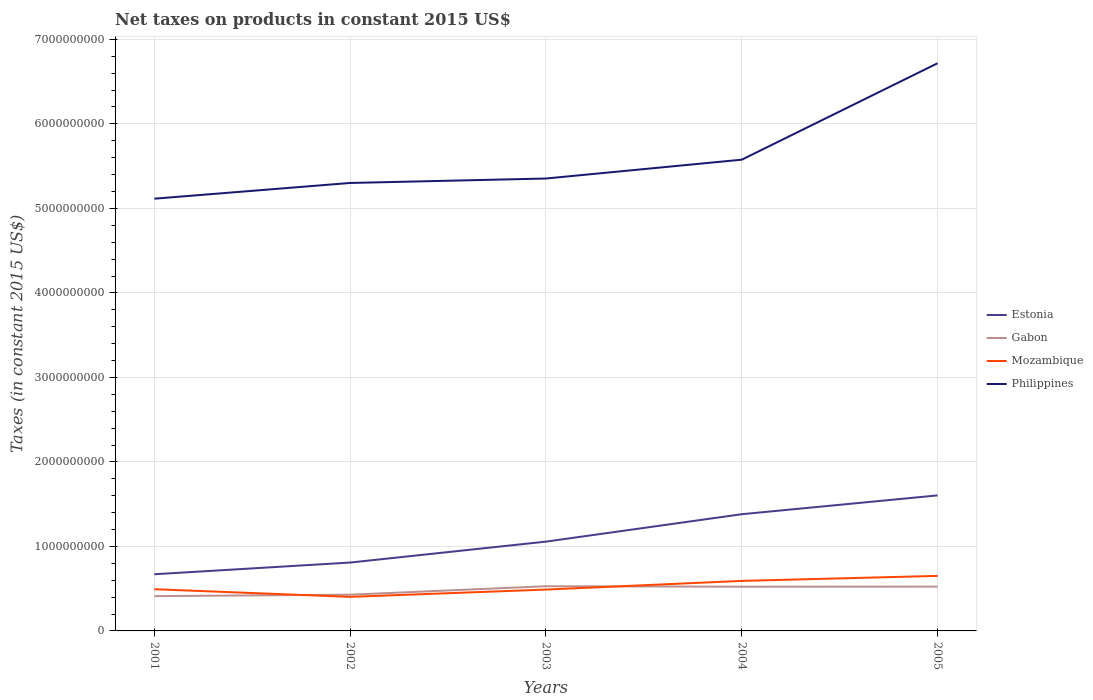Does the line corresponding to Estonia intersect with the line corresponding to Philippines?
Give a very brief answer. No. Is the number of lines equal to the number of legend labels?
Provide a succinct answer. Yes. Across all years, what is the maximum net taxes on products in Gabon?
Keep it short and to the point. 4.12e+08. In which year was the net taxes on products in Estonia maximum?
Offer a terse response. 2001. What is the total net taxes on products in Gabon in the graph?
Give a very brief answer. -1.13e+08. What is the difference between the highest and the second highest net taxes on products in Mozambique?
Your answer should be very brief. 2.48e+08. What is the difference between the highest and the lowest net taxes on products in Gabon?
Your answer should be compact. 3. What is the difference between two consecutive major ticks on the Y-axis?
Keep it short and to the point. 1.00e+09. Are the values on the major ticks of Y-axis written in scientific E-notation?
Provide a short and direct response. No. Does the graph contain any zero values?
Ensure brevity in your answer.  No. Does the graph contain grids?
Offer a terse response. Yes. How many legend labels are there?
Provide a succinct answer. 4. What is the title of the graph?
Make the answer very short. Net taxes on products in constant 2015 US$. What is the label or title of the Y-axis?
Keep it short and to the point. Taxes (in constant 2015 US$). What is the Taxes (in constant 2015 US$) in Estonia in 2001?
Offer a very short reply. 6.71e+08. What is the Taxes (in constant 2015 US$) of Gabon in 2001?
Provide a short and direct response. 4.12e+08. What is the Taxes (in constant 2015 US$) in Mozambique in 2001?
Your response must be concise. 4.94e+08. What is the Taxes (in constant 2015 US$) in Philippines in 2001?
Your answer should be very brief. 5.11e+09. What is the Taxes (in constant 2015 US$) of Estonia in 2002?
Make the answer very short. 8.09e+08. What is the Taxes (in constant 2015 US$) of Gabon in 2002?
Provide a succinct answer. 4.29e+08. What is the Taxes (in constant 2015 US$) of Mozambique in 2002?
Your answer should be compact. 4.03e+08. What is the Taxes (in constant 2015 US$) of Philippines in 2002?
Your answer should be compact. 5.30e+09. What is the Taxes (in constant 2015 US$) in Estonia in 2003?
Give a very brief answer. 1.06e+09. What is the Taxes (in constant 2015 US$) of Gabon in 2003?
Your answer should be compact. 5.29e+08. What is the Taxes (in constant 2015 US$) of Mozambique in 2003?
Your answer should be very brief. 4.89e+08. What is the Taxes (in constant 2015 US$) of Philippines in 2003?
Make the answer very short. 5.35e+09. What is the Taxes (in constant 2015 US$) of Estonia in 2004?
Your answer should be compact. 1.38e+09. What is the Taxes (in constant 2015 US$) in Gabon in 2004?
Give a very brief answer. 5.23e+08. What is the Taxes (in constant 2015 US$) in Mozambique in 2004?
Offer a terse response. 5.92e+08. What is the Taxes (in constant 2015 US$) of Philippines in 2004?
Your response must be concise. 5.58e+09. What is the Taxes (in constant 2015 US$) in Estonia in 2005?
Provide a short and direct response. 1.60e+09. What is the Taxes (in constant 2015 US$) in Gabon in 2005?
Your response must be concise. 5.24e+08. What is the Taxes (in constant 2015 US$) of Mozambique in 2005?
Give a very brief answer. 6.51e+08. What is the Taxes (in constant 2015 US$) of Philippines in 2005?
Provide a succinct answer. 6.72e+09. Across all years, what is the maximum Taxes (in constant 2015 US$) of Estonia?
Keep it short and to the point. 1.60e+09. Across all years, what is the maximum Taxes (in constant 2015 US$) of Gabon?
Provide a short and direct response. 5.29e+08. Across all years, what is the maximum Taxes (in constant 2015 US$) in Mozambique?
Keep it short and to the point. 6.51e+08. Across all years, what is the maximum Taxes (in constant 2015 US$) in Philippines?
Give a very brief answer. 6.72e+09. Across all years, what is the minimum Taxes (in constant 2015 US$) of Estonia?
Your answer should be very brief. 6.71e+08. Across all years, what is the minimum Taxes (in constant 2015 US$) of Gabon?
Ensure brevity in your answer.  4.12e+08. Across all years, what is the minimum Taxes (in constant 2015 US$) of Mozambique?
Provide a short and direct response. 4.03e+08. Across all years, what is the minimum Taxes (in constant 2015 US$) in Philippines?
Make the answer very short. 5.11e+09. What is the total Taxes (in constant 2015 US$) in Estonia in the graph?
Make the answer very short. 5.52e+09. What is the total Taxes (in constant 2015 US$) in Gabon in the graph?
Your answer should be very brief. 2.42e+09. What is the total Taxes (in constant 2015 US$) in Mozambique in the graph?
Keep it short and to the point. 2.63e+09. What is the total Taxes (in constant 2015 US$) in Philippines in the graph?
Provide a short and direct response. 2.81e+1. What is the difference between the Taxes (in constant 2015 US$) of Estonia in 2001 and that in 2002?
Keep it short and to the point. -1.38e+08. What is the difference between the Taxes (in constant 2015 US$) of Gabon in 2001 and that in 2002?
Offer a very short reply. -1.71e+07. What is the difference between the Taxes (in constant 2015 US$) of Mozambique in 2001 and that in 2002?
Offer a terse response. 9.05e+07. What is the difference between the Taxes (in constant 2015 US$) in Philippines in 2001 and that in 2002?
Give a very brief answer. -1.86e+08. What is the difference between the Taxes (in constant 2015 US$) in Estonia in 2001 and that in 2003?
Ensure brevity in your answer.  -3.86e+08. What is the difference between the Taxes (in constant 2015 US$) of Gabon in 2001 and that in 2003?
Provide a short and direct response. -1.17e+08. What is the difference between the Taxes (in constant 2015 US$) of Mozambique in 2001 and that in 2003?
Make the answer very short. 4.09e+06. What is the difference between the Taxes (in constant 2015 US$) of Philippines in 2001 and that in 2003?
Ensure brevity in your answer.  -2.39e+08. What is the difference between the Taxes (in constant 2015 US$) in Estonia in 2001 and that in 2004?
Your answer should be very brief. -7.10e+08. What is the difference between the Taxes (in constant 2015 US$) of Gabon in 2001 and that in 2004?
Your response must be concise. -1.12e+08. What is the difference between the Taxes (in constant 2015 US$) of Mozambique in 2001 and that in 2004?
Ensure brevity in your answer.  -9.84e+07. What is the difference between the Taxes (in constant 2015 US$) of Philippines in 2001 and that in 2004?
Give a very brief answer. -4.62e+08. What is the difference between the Taxes (in constant 2015 US$) in Estonia in 2001 and that in 2005?
Your answer should be compact. -9.33e+08. What is the difference between the Taxes (in constant 2015 US$) in Gabon in 2001 and that in 2005?
Offer a terse response. -1.13e+08. What is the difference between the Taxes (in constant 2015 US$) in Mozambique in 2001 and that in 2005?
Give a very brief answer. -1.58e+08. What is the difference between the Taxes (in constant 2015 US$) of Philippines in 2001 and that in 2005?
Ensure brevity in your answer.  -1.60e+09. What is the difference between the Taxes (in constant 2015 US$) in Estonia in 2002 and that in 2003?
Give a very brief answer. -2.48e+08. What is the difference between the Taxes (in constant 2015 US$) in Gabon in 2002 and that in 2003?
Provide a short and direct response. -1.00e+08. What is the difference between the Taxes (in constant 2015 US$) in Mozambique in 2002 and that in 2003?
Offer a very short reply. -8.65e+07. What is the difference between the Taxes (in constant 2015 US$) of Philippines in 2002 and that in 2003?
Give a very brief answer. -5.27e+07. What is the difference between the Taxes (in constant 2015 US$) of Estonia in 2002 and that in 2004?
Your answer should be very brief. -5.72e+08. What is the difference between the Taxes (in constant 2015 US$) of Gabon in 2002 and that in 2004?
Ensure brevity in your answer.  -9.45e+07. What is the difference between the Taxes (in constant 2015 US$) of Mozambique in 2002 and that in 2004?
Your answer should be very brief. -1.89e+08. What is the difference between the Taxes (in constant 2015 US$) in Philippines in 2002 and that in 2004?
Ensure brevity in your answer.  -2.76e+08. What is the difference between the Taxes (in constant 2015 US$) in Estonia in 2002 and that in 2005?
Your response must be concise. -7.95e+08. What is the difference between the Taxes (in constant 2015 US$) in Gabon in 2002 and that in 2005?
Make the answer very short. -9.55e+07. What is the difference between the Taxes (in constant 2015 US$) in Mozambique in 2002 and that in 2005?
Ensure brevity in your answer.  -2.48e+08. What is the difference between the Taxes (in constant 2015 US$) of Philippines in 2002 and that in 2005?
Make the answer very short. -1.42e+09. What is the difference between the Taxes (in constant 2015 US$) of Estonia in 2003 and that in 2004?
Provide a succinct answer. -3.24e+08. What is the difference between the Taxes (in constant 2015 US$) of Gabon in 2003 and that in 2004?
Give a very brief answer. 5.57e+06. What is the difference between the Taxes (in constant 2015 US$) of Mozambique in 2003 and that in 2004?
Make the answer very short. -1.03e+08. What is the difference between the Taxes (in constant 2015 US$) in Philippines in 2003 and that in 2004?
Your answer should be very brief. -2.23e+08. What is the difference between the Taxes (in constant 2015 US$) in Estonia in 2003 and that in 2005?
Keep it short and to the point. -5.47e+08. What is the difference between the Taxes (in constant 2015 US$) in Gabon in 2003 and that in 2005?
Your response must be concise. 4.59e+06. What is the difference between the Taxes (in constant 2015 US$) of Mozambique in 2003 and that in 2005?
Provide a succinct answer. -1.62e+08. What is the difference between the Taxes (in constant 2015 US$) in Philippines in 2003 and that in 2005?
Make the answer very short. -1.36e+09. What is the difference between the Taxes (in constant 2015 US$) of Estonia in 2004 and that in 2005?
Provide a short and direct response. -2.23e+08. What is the difference between the Taxes (in constant 2015 US$) of Gabon in 2004 and that in 2005?
Make the answer very short. -9.85e+05. What is the difference between the Taxes (in constant 2015 US$) in Mozambique in 2004 and that in 2005?
Your answer should be very brief. -5.92e+07. What is the difference between the Taxes (in constant 2015 US$) of Philippines in 2004 and that in 2005?
Offer a very short reply. -1.14e+09. What is the difference between the Taxes (in constant 2015 US$) of Estonia in 2001 and the Taxes (in constant 2015 US$) of Gabon in 2002?
Ensure brevity in your answer.  2.42e+08. What is the difference between the Taxes (in constant 2015 US$) of Estonia in 2001 and the Taxes (in constant 2015 US$) of Mozambique in 2002?
Your answer should be compact. 2.68e+08. What is the difference between the Taxes (in constant 2015 US$) of Estonia in 2001 and the Taxes (in constant 2015 US$) of Philippines in 2002?
Keep it short and to the point. -4.63e+09. What is the difference between the Taxes (in constant 2015 US$) of Gabon in 2001 and the Taxes (in constant 2015 US$) of Mozambique in 2002?
Keep it short and to the point. 8.76e+06. What is the difference between the Taxes (in constant 2015 US$) of Gabon in 2001 and the Taxes (in constant 2015 US$) of Philippines in 2002?
Offer a very short reply. -4.89e+09. What is the difference between the Taxes (in constant 2015 US$) of Mozambique in 2001 and the Taxes (in constant 2015 US$) of Philippines in 2002?
Your response must be concise. -4.81e+09. What is the difference between the Taxes (in constant 2015 US$) in Estonia in 2001 and the Taxes (in constant 2015 US$) in Gabon in 2003?
Give a very brief answer. 1.42e+08. What is the difference between the Taxes (in constant 2015 US$) in Estonia in 2001 and the Taxes (in constant 2015 US$) in Mozambique in 2003?
Give a very brief answer. 1.81e+08. What is the difference between the Taxes (in constant 2015 US$) of Estonia in 2001 and the Taxes (in constant 2015 US$) of Philippines in 2003?
Provide a short and direct response. -4.68e+09. What is the difference between the Taxes (in constant 2015 US$) of Gabon in 2001 and the Taxes (in constant 2015 US$) of Mozambique in 2003?
Keep it short and to the point. -7.77e+07. What is the difference between the Taxes (in constant 2015 US$) of Gabon in 2001 and the Taxes (in constant 2015 US$) of Philippines in 2003?
Offer a terse response. -4.94e+09. What is the difference between the Taxes (in constant 2015 US$) of Mozambique in 2001 and the Taxes (in constant 2015 US$) of Philippines in 2003?
Ensure brevity in your answer.  -4.86e+09. What is the difference between the Taxes (in constant 2015 US$) of Estonia in 2001 and the Taxes (in constant 2015 US$) of Gabon in 2004?
Your response must be concise. 1.47e+08. What is the difference between the Taxes (in constant 2015 US$) of Estonia in 2001 and the Taxes (in constant 2015 US$) of Mozambique in 2004?
Keep it short and to the point. 7.87e+07. What is the difference between the Taxes (in constant 2015 US$) of Estonia in 2001 and the Taxes (in constant 2015 US$) of Philippines in 2004?
Give a very brief answer. -4.91e+09. What is the difference between the Taxes (in constant 2015 US$) of Gabon in 2001 and the Taxes (in constant 2015 US$) of Mozambique in 2004?
Your response must be concise. -1.80e+08. What is the difference between the Taxes (in constant 2015 US$) in Gabon in 2001 and the Taxes (in constant 2015 US$) in Philippines in 2004?
Your response must be concise. -5.16e+09. What is the difference between the Taxes (in constant 2015 US$) of Mozambique in 2001 and the Taxes (in constant 2015 US$) of Philippines in 2004?
Make the answer very short. -5.08e+09. What is the difference between the Taxes (in constant 2015 US$) of Estonia in 2001 and the Taxes (in constant 2015 US$) of Gabon in 2005?
Give a very brief answer. 1.46e+08. What is the difference between the Taxes (in constant 2015 US$) in Estonia in 2001 and the Taxes (in constant 2015 US$) in Mozambique in 2005?
Your answer should be very brief. 1.95e+07. What is the difference between the Taxes (in constant 2015 US$) of Estonia in 2001 and the Taxes (in constant 2015 US$) of Philippines in 2005?
Your answer should be compact. -6.05e+09. What is the difference between the Taxes (in constant 2015 US$) in Gabon in 2001 and the Taxes (in constant 2015 US$) in Mozambique in 2005?
Offer a very short reply. -2.39e+08. What is the difference between the Taxes (in constant 2015 US$) of Gabon in 2001 and the Taxes (in constant 2015 US$) of Philippines in 2005?
Your answer should be compact. -6.31e+09. What is the difference between the Taxes (in constant 2015 US$) in Mozambique in 2001 and the Taxes (in constant 2015 US$) in Philippines in 2005?
Offer a terse response. -6.22e+09. What is the difference between the Taxes (in constant 2015 US$) in Estonia in 2002 and the Taxes (in constant 2015 US$) in Gabon in 2003?
Your answer should be very brief. 2.80e+08. What is the difference between the Taxes (in constant 2015 US$) in Estonia in 2002 and the Taxes (in constant 2015 US$) in Mozambique in 2003?
Provide a succinct answer. 3.20e+08. What is the difference between the Taxes (in constant 2015 US$) in Estonia in 2002 and the Taxes (in constant 2015 US$) in Philippines in 2003?
Provide a short and direct response. -4.54e+09. What is the difference between the Taxes (in constant 2015 US$) of Gabon in 2002 and the Taxes (in constant 2015 US$) of Mozambique in 2003?
Provide a succinct answer. -6.06e+07. What is the difference between the Taxes (in constant 2015 US$) of Gabon in 2002 and the Taxes (in constant 2015 US$) of Philippines in 2003?
Provide a short and direct response. -4.92e+09. What is the difference between the Taxes (in constant 2015 US$) of Mozambique in 2002 and the Taxes (in constant 2015 US$) of Philippines in 2003?
Make the answer very short. -4.95e+09. What is the difference between the Taxes (in constant 2015 US$) in Estonia in 2002 and the Taxes (in constant 2015 US$) in Gabon in 2004?
Keep it short and to the point. 2.86e+08. What is the difference between the Taxes (in constant 2015 US$) in Estonia in 2002 and the Taxes (in constant 2015 US$) in Mozambique in 2004?
Your answer should be very brief. 2.17e+08. What is the difference between the Taxes (in constant 2015 US$) in Estonia in 2002 and the Taxes (in constant 2015 US$) in Philippines in 2004?
Offer a terse response. -4.77e+09. What is the difference between the Taxes (in constant 2015 US$) of Gabon in 2002 and the Taxes (in constant 2015 US$) of Mozambique in 2004?
Your answer should be compact. -1.63e+08. What is the difference between the Taxes (in constant 2015 US$) of Gabon in 2002 and the Taxes (in constant 2015 US$) of Philippines in 2004?
Provide a succinct answer. -5.15e+09. What is the difference between the Taxes (in constant 2015 US$) in Mozambique in 2002 and the Taxes (in constant 2015 US$) in Philippines in 2004?
Your answer should be compact. -5.17e+09. What is the difference between the Taxes (in constant 2015 US$) of Estonia in 2002 and the Taxes (in constant 2015 US$) of Gabon in 2005?
Ensure brevity in your answer.  2.85e+08. What is the difference between the Taxes (in constant 2015 US$) of Estonia in 2002 and the Taxes (in constant 2015 US$) of Mozambique in 2005?
Provide a succinct answer. 1.58e+08. What is the difference between the Taxes (in constant 2015 US$) in Estonia in 2002 and the Taxes (in constant 2015 US$) in Philippines in 2005?
Make the answer very short. -5.91e+09. What is the difference between the Taxes (in constant 2015 US$) of Gabon in 2002 and the Taxes (in constant 2015 US$) of Mozambique in 2005?
Your answer should be very brief. -2.22e+08. What is the difference between the Taxes (in constant 2015 US$) in Gabon in 2002 and the Taxes (in constant 2015 US$) in Philippines in 2005?
Provide a succinct answer. -6.29e+09. What is the difference between the Taxes (in constant 2015 US$) of Mozambique in 2002 and the Taxes (in constant 2015 US$) of Philippines in 2005?
Your answer should be compact. -6.31e+09. What is the difference between the Taxes (in constant 2015 US$) of Estonia in 2003 and the Taxes (in constant 2015 US$) of Gabon in 2004?
Make the answer very short. 5.33e+08. What is the difference between the Taxes (in constant 2015 US$) in Estonia in 2003 and the Taxes (in constant 2015 US$) in Mozambique in 2004?
Make the answer very short. 4.65e+08. What is the difference between the Taxes (in constant 2015 US$) of Estonia in 2003 and the Taxes (in constant 2015 US$) of Philippines in 2004?
Your response must be concise. -4.52e+09. What is the difference between the Taxes (in constant 2015 US$) in Gabon in 2003 and the Taxes (in constant 2015 US$) in Mozambique in 2004?
Ensure brevity in your answer.  -6.31e+07. What is the difference between the Taxes (in constant 2015 US$) in Gabon in 2003 and the Taxes (in constant 2015 US$) in Philippines in 2004?
Provide a succinct answer. -5.05e+09. What is the difference between the Taxes (in constant 2015 US$) in Mozambique in 2003 and the Taxes (in constant 2015 US$) in Philippines in 2004?
Provide a succinct answer. -5.09e+09. What is the difference between the Taxes (in constant 2015 US$) in Estonia in 2003 and the Taxes (in constant 2015 US$) in Gabon in 2005?
Provide a succinct answer. 5.32e+08. What is the difference between the Taxes (in constant 2015 US$) of Estonia in 2003 and the Taxes (in constant 2015 US$) of Mozambique in 2005?
Your response must be concise. 4.06e+08. What is the difference between the Taxes (in constant 2015 US$) of Estonia in 2003 and the Taxes (in constant 2015 US$) of Philippines in 2005?
Your answer should be very brief. -5.66e+09. What is the difference between the Taxes (in constant 2015 US$) of Gabon in 2003 and the Taxes (in constant 2015 US$) of Mozambique in 2005?
Offer a very short reply. -1.22e+08. What is the difference between the Taxes (in constant 2015 US$) of Gabon in 2003 and the Taxes (in constant 2015 US$) of Philippines in 2005?
Give a very brief answer. -6.19e+09. What is the difference between the Taxes (in constant 2015 US$) of Mozambique in 2003 and the Taxes (in constant 2015 US$) of Philippines in 2005?
Offer a very short reply. -6.23e+09. What is the difference between the Taxes (in constant 2015 US$) of Estonia in 2004 and the Taxes (in constant 2015 US$) of Gabon in 2005?
Give a very brief answer. 8.57e+08. What is the difference between the Taxes (in constant 2015 US$) in Estonia in 2004 and the Taxes (in constant 2015 US$) in Mozambique in 2005?
Your response must be concise. 7.30e+08. What is the difference between the Taxes (in constant 2015 US$) in Estonia in 2004 and the Taxes (in constant 2015 US$) in Philippines in 2005?
Provide a short and direct response. -5.34e+09. What is the difference between the Taxes (in constant 2015 US$) in Gabon in 2004 and the Taxes (in constant 2015 US$) in Mozambique in 2005?
Offer a very short reply. -1.28e+08. What is the difference between the Taxes (in constant 2015 US$) of Gabon in 2004 and the Taxes (in constant 2015 US$) of Philippines in 2005?
Keep it short and to the point. -6.19e+09. What is the difference between the Taxes (in constant 2015 US$) of Mozambique in 2004 and the Taxes (in constant 2015 US$) of Philippines in 2005?
Provide a short and direct response. -6.13e+09. What is the average Taxes (in constant 2015 US$) of Estonia per year?
Keep it short and to the point. 1.10e+09. What is the average Taxes (in constant 2015 US$) in Gabon per year?
Give a very brief answer. 4.83e+08. What is the average Taxes (in constant 2015 US$) of Mozambique per year?
Make the answer very short. 5.26e+08. What is the average Taxes (in constant 2015 US$) of Philippines per year?
Your response must be concise. 5.61e+09. In the year 2001, what is the difference between the Taxes (in constant 2015 US$) of Estonia and Taxes (in constant 2015 US$) of Gabon?
Ensure brevity in your answer.  2.59e+08. In the year 2001, what is the difference between the Taxes (in constant 2015 US$) of Estonia and Taxes (in constant 2015 US$) of Mozambique?
Ensure brevity in your answer.  1.77e+08. In the year 2001, what is the difference between the Taxes (in constant 2015 US$) of Estonia and Taxes (in constant 2015 US$) of Philippines?
Your answer should be very brief. -4.44e+09. In the year 2001, what is the difference between the Taxes (in constant 2015 US$) of Gabon and Taxes (in constant 2015 US$) of Mozambique?
Offer a terse response. -8.18e+07. In the year 2001, what is the difference between the Taxes (in constant 2015 US$) of Gabon and Taxes (in constant 2015 US$) of Philippines?
Your answer should be very brief. -4.70e+09. In the year 2001, what is the difference between the Taxes (in constant 2015 US$) in Mozambique and Taxes (in constant 2015 US$) in Philippines?
Offer a terse response. -4.62e+09. In the year 2002, what is the difference between the Taxes (in constant 2015 US$) in Estonia and Taxes (in constant 2015 US$) in Gabon?
Your answer should be very brief. 3.80e+08. In the year 2002, what is the difference between the Taxes (in constant 2015 US$) of Estonia and Taxes (in constant 2015 US$) of Mozambique?
Your response must be concise. 4.06e+08. In the year 2002, what is the difference between the Taxes (in constant 2015 US$) of Estonia and Taxes (in constant 2015 US$) of Philippines?
Offer a terse response. -4.49e+09. In the year 2002, what is the difference between the Taxes (in constant 2015 US$) of Gabon and Taxes (in constant 2015 US$) of Mozambique?
Your response must be concise. 2.58e+07. In the year 2002, what is the difference between the Taxes (in constant 2015 US$) in Gabon and Taxes (in constant 2015 US$) in Philippines?
Make the answer very short. -4.87e+09. In the year 2002, what is the difference between the Taxes (in constant 2015 US$) in Mozambique and Taxes (in constant 2015 US$) in Philippines?
Your answer should be compact. -4.90e+09. In the year 2003, what is the difference between the Taxes (in constant 2015 US$) in Estonia and Taxes (in constant 2015 US$) in Gabon?
Your response must be concise. 5.28e+08. In the year 2003, what is the difference between the Taxes (in constant 2015 US$) in Estonia and Taxes (in constant 2015 US$) in Mozambique?
Keep it short and to the point. 5.67e+08. In the year 2003, what is the difference between the Taxes (in constant 2015 US$) of Estonia and Taxes (in constant 2015 US$) of Philippines?
Your answer should be very brief. -4.30e+09. In the year 2003, what is the difference between the Taxes (in constant 2015 US$) of Gabon and Taxes (in constant 2015 US$) of Mozambique?
Ensure brevity in your answer.  3.95e+07. In the year 2003, what is the difference between the Taxes (in constant 2015 US$) in Gabon and Taxes (in constant 2015 US$) in Philippines?
Your response must be concise. -4.82e+09. In the year 2003, what is the difference between the Taxes (in constant 2015 US$) in Mozambique and Taxes (in constant 2015 US$) in Philippines?
Provide a short and direct response. -4.86e+09. In the year 2004, what is the difference between the Taxes (in constant 2015 US$) in Estonia and Taxes (in constant 2015 US$) in Gabon?
Your response must be concise. 8.58e+08. In the year 2004, what is the difference between the Taxes (in constant 2015 US$) of Estonia and Taxes (in constant 2015 US$) of Mozambique?
Ensure brevity in your answer.  7.89e+08. In the year 2004, what is the difference between the Taxes (in constant 2015 US$) in Estonia and Taxes (in constant 2015 US$) in Philippines?
Provide a succinct answer. -4.20e+09. In the year 2004, what is the difference between the Taxes (in constant 2015 US$) in Gabon and Taxes (in constant 2015 US$) in Mozambique?
Provide a succinct answer. -6.86e+07. In the year 2004, what is the difference between the Taxes (in constant 2015 US$) of Gabon and Taxes (in constant 2015 US$) of Philippines?
Offer a very short reply. -5.05e+09. In the year 2004, what is the difference between the Taxes (in constant 2015 US$) in Mozambique and Taxes (in constant 2015 US$) in Philippines?
Your response must be concise. -4.98e+09. In the year 2005, what is the difference between the Taxes (in constant 2015 US$) of Estonia and Taxes (in constant 2015 US$) of Gabon?
Give a very brief answer. 1.08e+09. In the year 2005, what is the difference between the Taxes (in constant 2015 US$) in Estonia and Taxes (in constant 2015 US$) in Mozambique?
Your answer should be very brief. 9.53e+08. In the year 2005, what is the difference between the Taxes (in constant 2015 US$) in Estonia and Taxes (in constant 2015 US$) in Philippines?
Keep it short and to the point. -5.11e+09. In the year 2005, what is the difference between the Taxes (in constant 2015 US$) of Gabon and Taxes (in constant 2015 US$) of Mozambique?
Provide a short and direct response. -1.27e+08. In the year 2005, what is the difference between the Taxes (in constant 2015 US$) in Gabon and Taxes (in constant 2015 US$) in Philippines?
Your response must be concise. -6.19e+09. In the year 2005, what is the difference between the Taxes (in constant 2015 US$) in Mozambique and Taxes (in constant 2015 US$) in Philippines?
Your response must be concise. -6.07e+09. What is the ratio of the Taxes (in constant 2015 US$) in Estonia in 2001 to that in 2002?
Ensure brevity in your answer.  0.83. What is the ratio of the Taxes (in constant 2015 US$) in Gabon in 2001 to that in 2002?
Your answer should be compact. 0.96. What is the ratio of the Taxes (in constant 2015 US$) of Mozambique in 2001 to that in 2002?
Provide a succinct answer. 1.22. What is the ratio of the Taxes (in constant 2015 US$) of Philippines in 2001 to that in 2002?
Your answer should be very brief. 0.96. What is the ratio of the Taxes (in constant 2015 US$) in Estonia in 2001 to that in 2003?
Give a very brief answer. 0.63. What is the ratio of the Taxes (in constant 2015 US$) of Gabon in 2001 to that in 2003?
Give a very brief answer. 0.78. What is the ratio of the Taxes (in constant 2015 US$) of Mozambique in 2001 to that in 2003?
Give a very brief answer. 1.01. What is the ratio of the Taxes (in constant 2015 US$) of Philippines in 2001 to that in 2003?
Your response must be concise. 0.96. What is the ratio of the Taxes (in constant 2015 US$) in Estonia in 2001 to that in 2004?
Give a very brief answer. 0.49. What is the ratio of the Taxes (in constant 2015 US$) in Gabon in 2001 to that in 2004?
Ensure brevity in your answer.  0.79. What is the ratio of the Taxes (in constant 2015 US$) in Mozambique in 2001 to that in 2004?
Give a very brief answer. 0.83. What is the ratio of the Taxes (in constant 2015 US$) of Philippines in 2001 to that in 2004?
Your response must be concise. 0.92. What is the ratio of the Taxes (in constant 2015 US$) in Estonia in 2001 to that in 2005?
Your response must be concise. 0.42. What is the ratio of the Taxes (in constant 2015 US$) of Gabon in 2001 to that in 2005?
Offer a very short reply. 0.79. What is the ratio of the Taxes (in constant 2015 US$) of Mozambique in 2001 to that in 2005?
Your answer should be very brief. 0.76. What is the ratio of the Taxes (in constant 2015 US$) in Philippines in 2001 to that in 2005?
Your response must be concise. 0.76. What is the ratio of the Taxes (in constant 2015 US$) in Estonia in 2002 to that in 2003?
Offer a very short reply. 0.77. What is the ratio of the Taxes (in constant 2015 US$) in Gabon in 2002 to that in 2003?
Make the answer very short. 0.81. What is the ratio of the Taxes (in constant 2015 US$) of Mozambique in 2002 to that in 2003?
Give a very brief answer. 0.82. What is the ratio of the Taxes (in constant 2015 US$) of Philippines in 2002 to that in 2003?
Make the answer very short. 0.99. What is the ratio of the Taxes (in constant 2015 US$) in Estonia in 2002 to that in 2004?
Your answer should be very brief. 0.59. What is the ratio of the Taxes (in constant 2015 US$) in Gabon in 2002 to that in 2004?
Keep it short and to the point. 0.82. What is the ratio of the Taxes (in constant 2015 US$) of Mozambique in 2002 to that in 2004?
Your answer should be very brief. 0.68. What is the ratio of the Taxes (in constant 2015 US$) in Philippines in 2002 to that in 2004?
Your response must be concise. 0.95. What is the ratio of the Taxes (in constant 2015 US$) in Estonia in 2002 to that in 2005?
Provide a short and direct response. 0.5. What is the ratio of the Taxes (in constant 2015 US$) in Gabon in 2002 to that in 2005?
Your answer should be compact. 0.82. What is the ratio of the Taxes (in constant 2015 US$) in Mozambique in 2002 to that in 2005?
Give a very brief answer. 0.62. What is the ratio of the Taxes (in constant 2015 US$) in Philippines in 2002 to that in 2005?
Your answer should be very brief. 0.79. What is the ratio of the Taxes (in constant 2015 US$) in Estonia in 2003 to that in 2004?
Provide a short and direct response. 0.77. What is the ratio of the Taxes (in constant 2015 US$) in Gabon in 2003 to that in 2004?
Your response must be concise. 1.01. What is the ratio of the Taxes (in constant 2015 US$) in Mozambique in 2003 to that in 2004?
Offer a very short reply. 0.83. What is the ratio of the Taxes (in constant 2015 US$) in Philippines in 2003 to that in 2004?
Keep it short and to the point. 0.96. What is the ratio of the Taxes (in constant 2015 US$) in Estonia in 2003 to that in 2005?
Your answer should be very brief. 0.66. What is the ratio of the Taxes (in constant 2015 US$) of Gabon in 2003 to that in 2005?
Offer a terse response. 1.01. What is the ratio of the Taxes (in constant 2015 US$) of Mozambique in 2003 to that in 2005?
Your answer should be compact. 0.75. What is the ratio of the Taxes (in constant 2015 US$) in Philippines in 2003 to that in 2005?
Your response must be concise. 0.8. What is the ratio of the Taxes (in constant 2015 US$) of Estonia in 2004 to that in 2005?
Provide a short and direct response. 0.86. What is the ratio of the Taxes (in constant 2015 US$) of Philippines in 2004 to that in 2005?
Offer a very short reply. 0.83. What is the difference between the highest and the second highest Taxes (in constant 2015 US$) of Estonia?
Offer a very short reply. 2.23e+08. What is the difference between the highest and the second highest Taxes (in constant 2015 US$) in Gabon?
Offer a terse response. 4.59e+06. What is the difference between the highest and the second highest Taxes (in constant 2015 US$) of Mozambique?
Keep it short and to the point. 5.92e+07. What is the difference between the highest and the second highest Taxes (in constant 2015 US$) of Philippines?
Offer a terse response. 1.14e+09. What is the difference between the highest and the lowest Taxes (in constant 2015 US$) of Estonia?
Offer a terse response. 9.33e+08. What is the difference between the highest and the lowest Taxes (in constant 2015 US$) in Gabon?
Make the answer very short. 1.17e+08. What is the difference between the highest and the lowest Taxes (in constant 2015 US$) of Mozambique?
Your answer should be compact. 2.48e+08. What is the difference between the highest and the lowest Taxes (in constant 2015 US$) of Philippines?
Ensure brevity in your answer.  1.60e+09. 